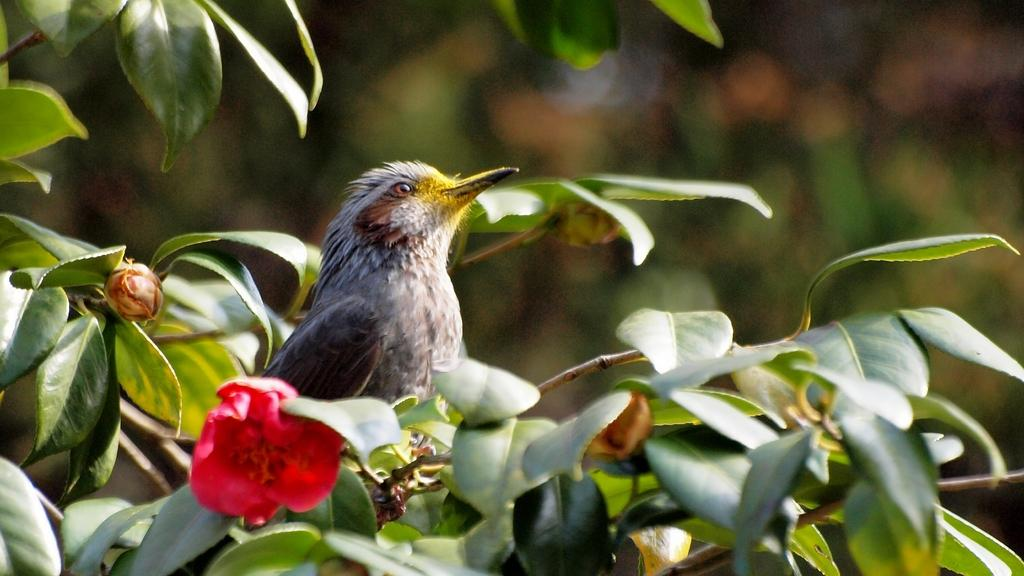What type of animal can be seen in the image? There is a bird in the image. Where is the bird located? The bird is sitting on a branch of a plant. What other features can be seen near the bird? There is a pink flower beside the bird. How does the bird maintain a quiet environment in the image? The bird's behavior or actions do not indicate any efforts to maintain a quiet environment in the image. 